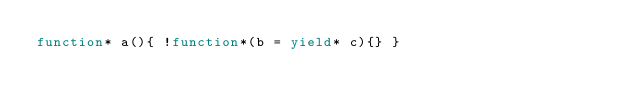<code> <loc_0><loc_0><loc_500><loc_500><_JavaScript_>function* a(){ !function*(b = yield* c){} }</code> 